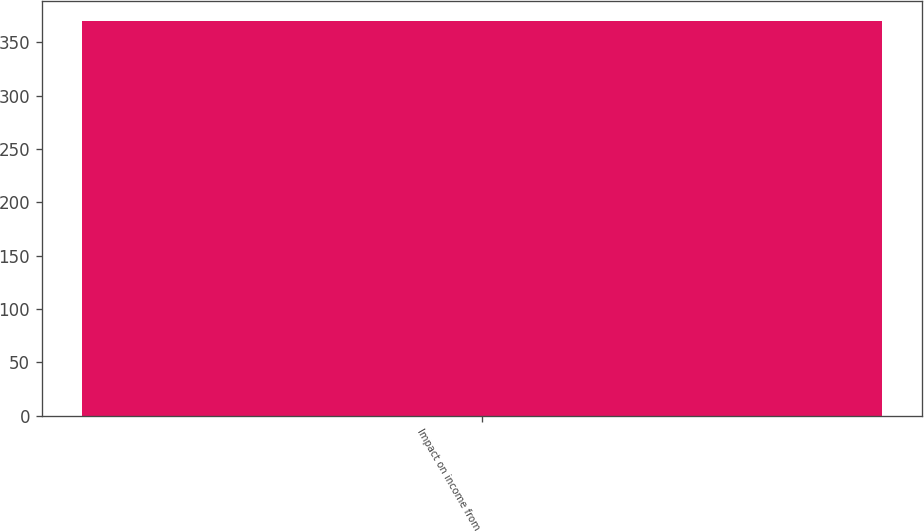Convert chart. <chart><loc_0><loc_0><loc_500><loc_500><bar_chart><fcel>Impact on income from<nl><fcel>370<nl></chart> 